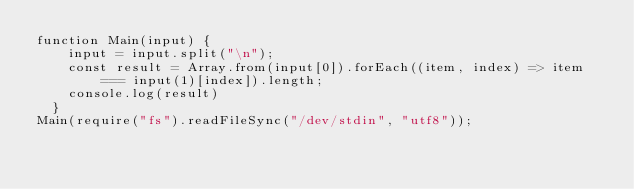<code> <loc_0><loc_0><loc_500><loc_500><_JavaScript_>function Main(input) {
    input = input.split("\n");
    const result = Array.from(input[0]).forEach((item, index) => item === input(1)[index]).length;
    console.log(result)
  }
Main(require("fs").readFileSync("/dev/stdin", "utf8"));</code> 